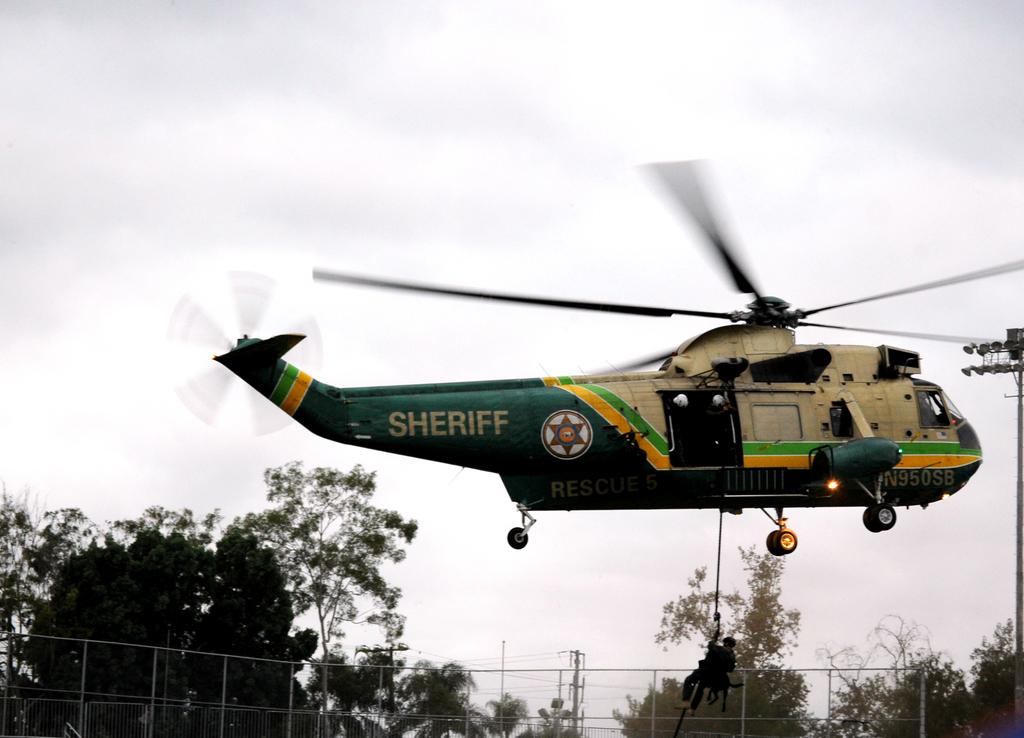What is the prominent word on the back half of the plane?
Give a very brief answer. Sheriff. What is this plane used for?
Your answer should be compact. Sheriff. 